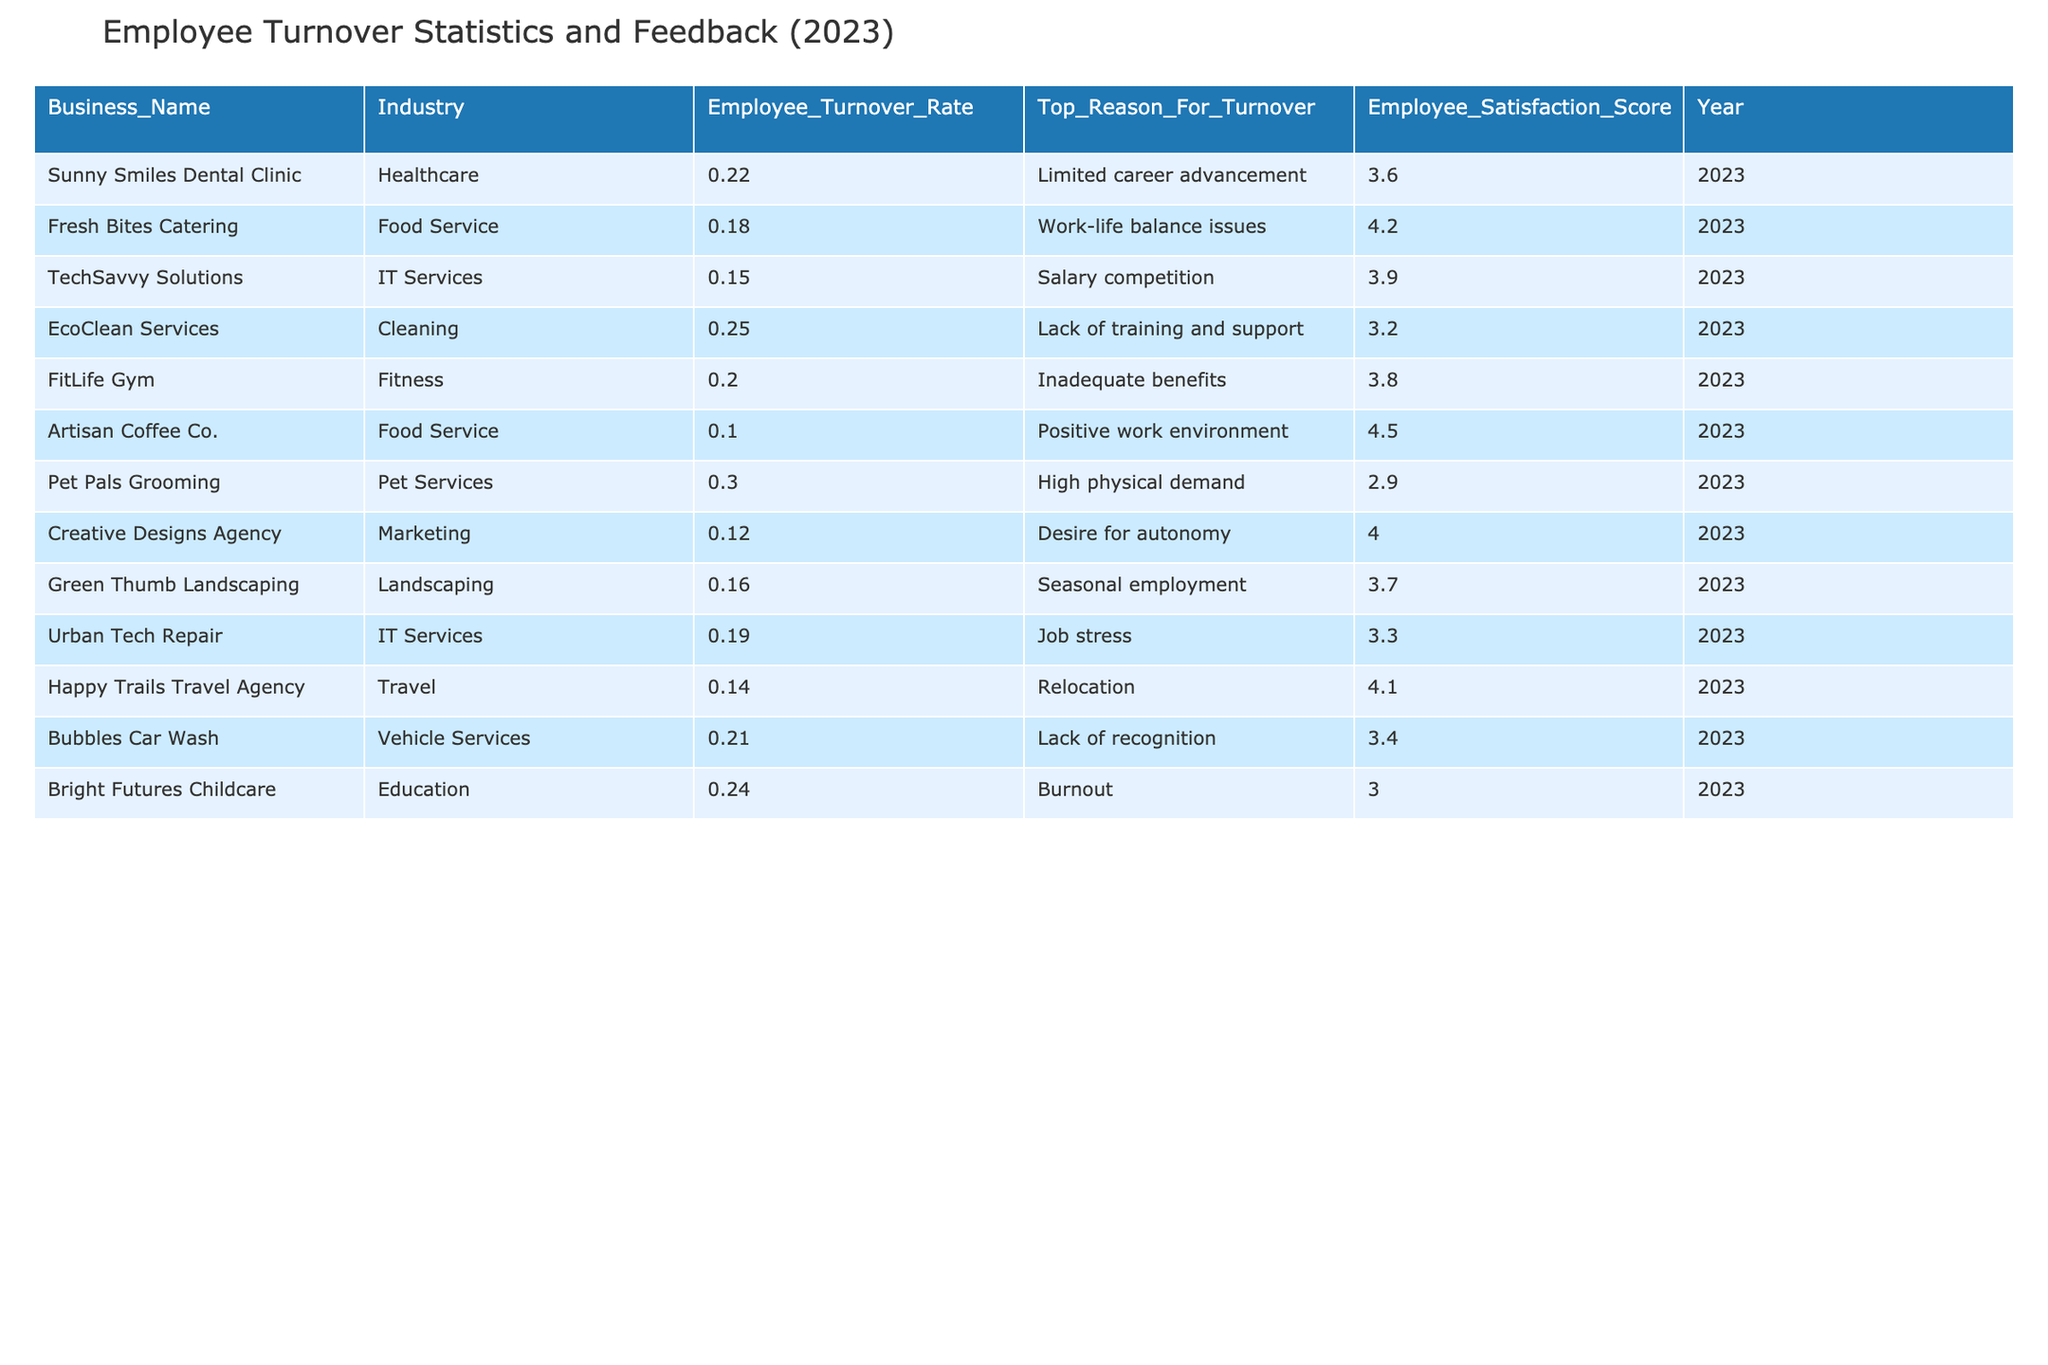What is the employee turnover rate for Artisan Coffee Co.? Looking at the table, the row for Artisan Coffee Co. shows an employee turnover rate of 10%.
Answer: 10% Which business has the highest employee turnover rate? By scanning through the table, I can see that Pet Pals Grooming has the highest turnover rate at 30%.
Answer: 30% What is the employee satisfaction score for EcoClean Services? In the table, the employee satisfaction score for EcoClean Services is listed as 3.2.
Answer: 3.2 What is the average employee turnover rate for the Food Service industry? To find the average, we look at the turnover rates for both Fresh Bites Catering (18%) and Artisan Coffee Co. (10%). So, (18 + 10) / 2 = 14%.
Answer: 14% Is the top reason for turnover at TechSavvy Solutions related to salary? The top reason for turnover at TechSavvy Solutions is listed as "Salary competition," which indicates a yes.
Answer: Yes Which business has the lowest employee satisfaction score, and what is that score? By analyzing the table, Bright Futures Childcare has the lowest satisfaction score, which is 3.0.
Answer: 3.0 How many businesses report "work-life balance issues" as a top reason for turnover? The only business that reports "work-life balance issues" is Fresh Bites Catering, making it one business.
Answer: 1 Which industry's businesses have an average satisfaction score below 3.5? Looking at the scores, EcoClean Services (3.2), Pet Pals Grooming (2.9), and Bright Futures Childcare (3.0) all belong to industries with average satisfaction scores below 3.5. Thus, the Cleaning and Pet Services industries both qualify.
Answer: Cleaning and Pet Services What is the difference in employee turnover rates between Urban Tech Repair and Creative Designs Agency? The turnover rate for Urban Tech Repair is 19%, and for Creative Designs Agency, it is 12%. Thus, the difference is 19 - 12 = 7%.
Answer: 7% 